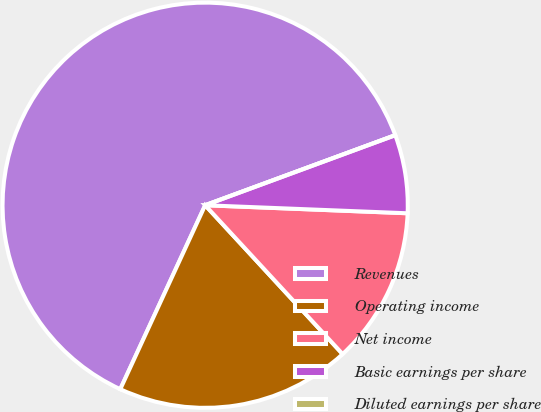<chart> <loc_0><loc_0><loc_500><loc_500><pie_chart><fcel>Revenues<fcel>Operating income<fcel>Net income<fcel>Basic earnings per share<fcel>Diluted earnings per share<nl><fcel>62.5%<fcel>18.75%<fcel>12.5%<fcel>6.25%<fcel>0.0%<nl></chart> 